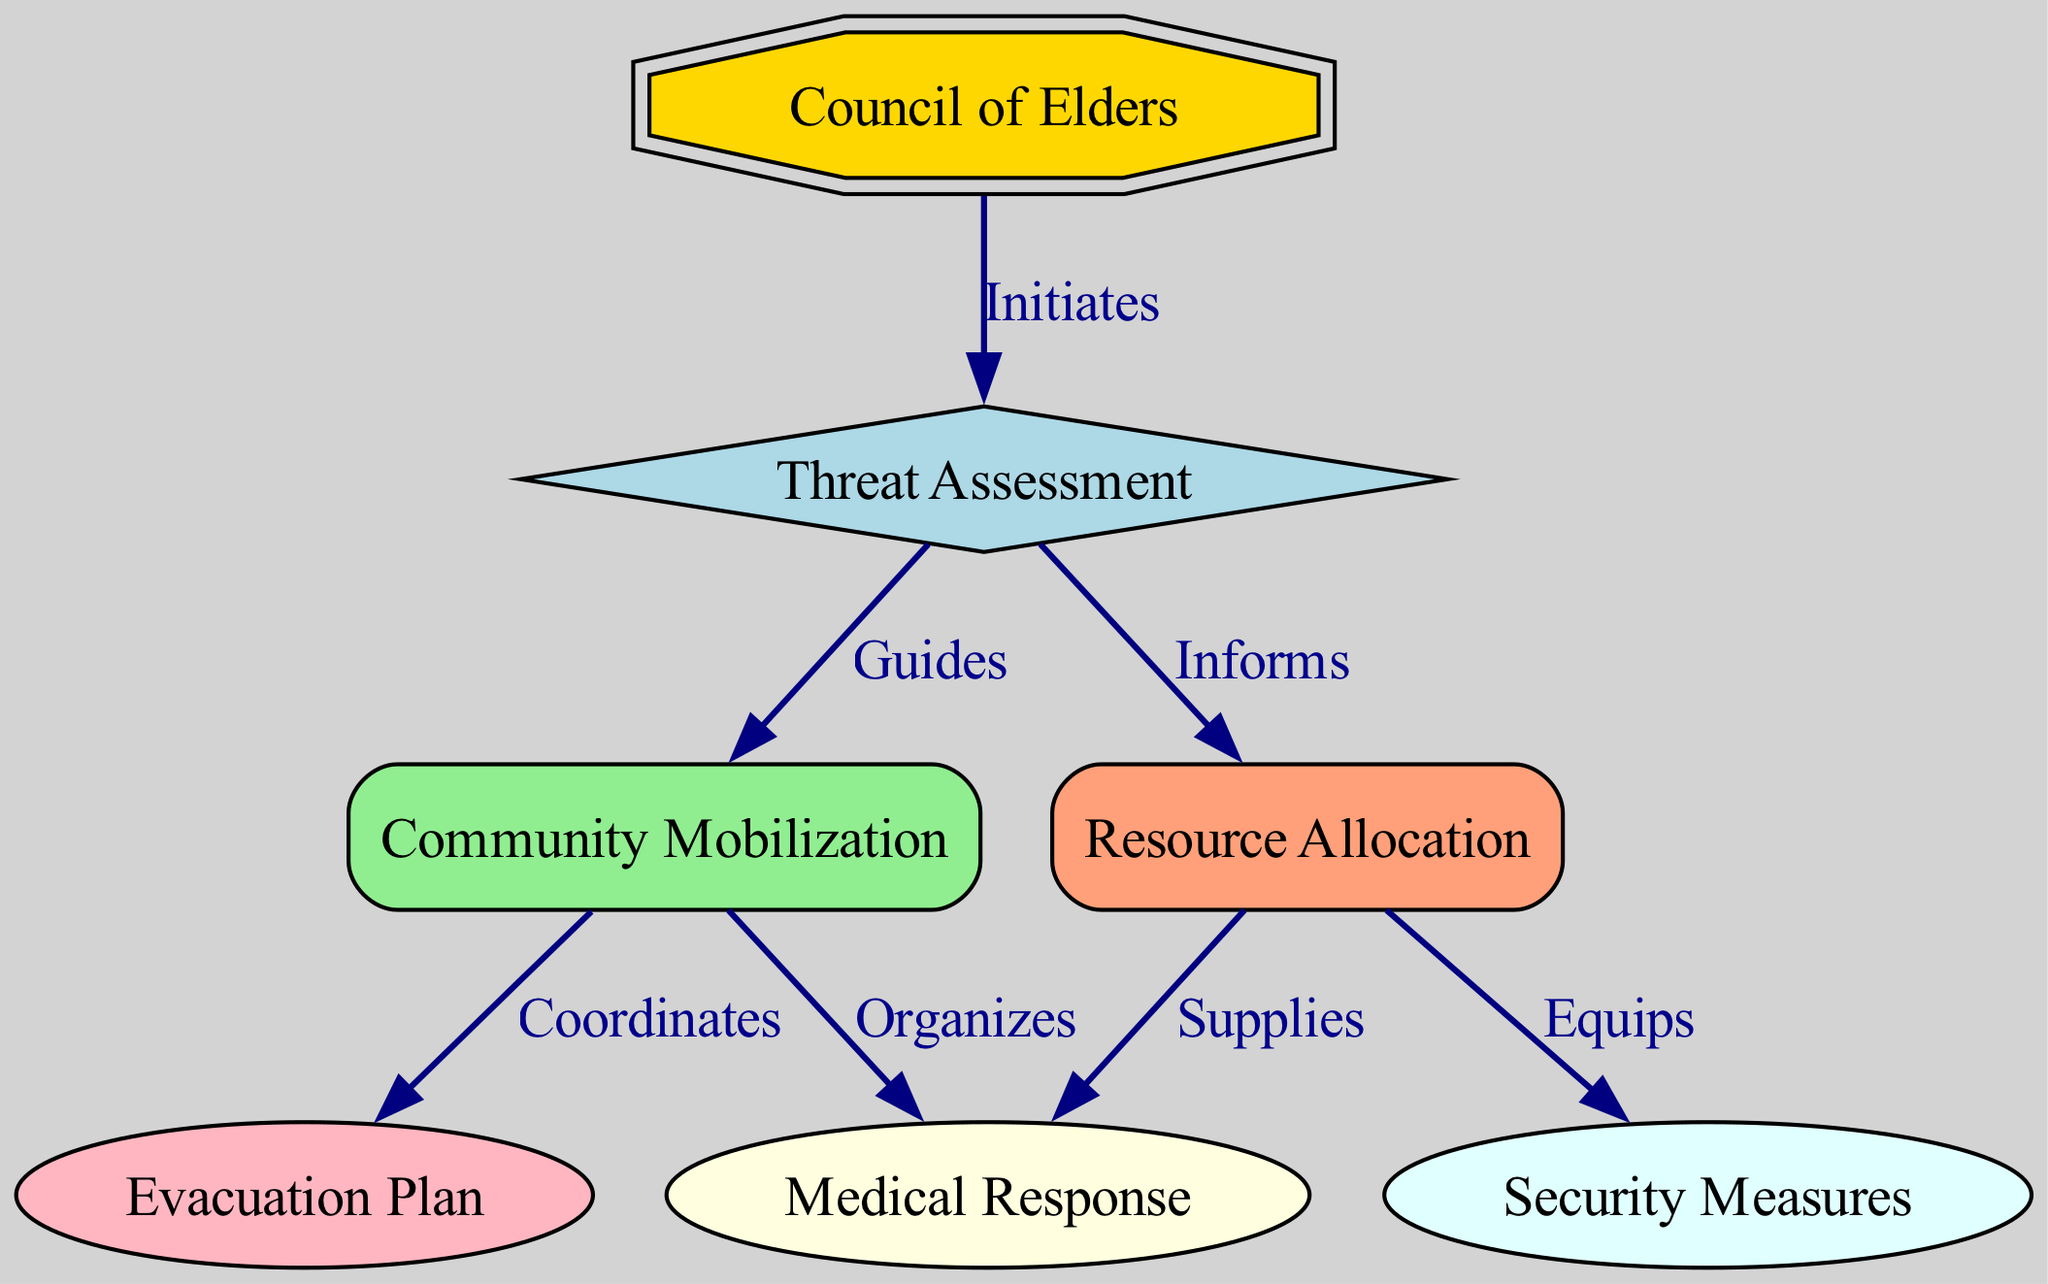What is the first node in the diagram? The diagram indicates that the first node is the "Council of Elders," as it is the starting point of the directed graph, which initiates the emergency response process.
Answer: Council of Elders How many nodes are in the diagram? The diagram lists a total of seven nodes, which include the Council of Elders, Threat Assessment, Community Mobilization, Resource Allocation, Evacuation Plan, Medical Response, and Security Measures.
Answer: Seven Which node directly follows the Threat Assessment node? The nodes connected to the Threat Assessment node are Community Mobilization and Resource Allocation, but the one that directly follows it in the flow of the diagram is Community Mobilization, as indicated by the directional edge.
Answer: Community Mobilization What action does the Council of Elders perform regarding Threat Assessment? The edge between the Council of Elders and Threat Assessment specifies that the Council of Elders "Initiates" the threat assessment process, indicating its role in starting this part of the response plan.
Answer: Initiates Which nodes are supplied by Resource Allocation? Resource Allocation directly supplies the Medical Response node, based on the edge labeled "Supplies," indicating that it provides resources necessary for medical assistance during emergencies.
Answer: Medical Response How do the nodes Community Mobilization and Evacuation Plan relate? Community Mobilization and Evacuation Plan are connected by the label "Coordinates," which indicates that the action of mobilizing the community is coordinated with the implementation of the evacuation plan.
Answer: Coordinates What is the role of the Threat Assessment node in the diagram? The Threat Assessment node performs a critical function as it guides community mobilization and informs resource allocation, highlighting its importance in assessing threats before actions are taken.
Answer: Guides and Informs Which node receives direct equipment from Resource Allocation? Resource Allocation directly equips the Security Measures node, as indicated by the edge labeled "Equips," showcasing the provision of necessary equipment for security during emergencies.
Answer: Security Measures How many edges are there in the diagram? The diagram contains eight edges that represent the various relationships and actions taken between the different nodes involving the emergency response plan.
Answer: Eight 